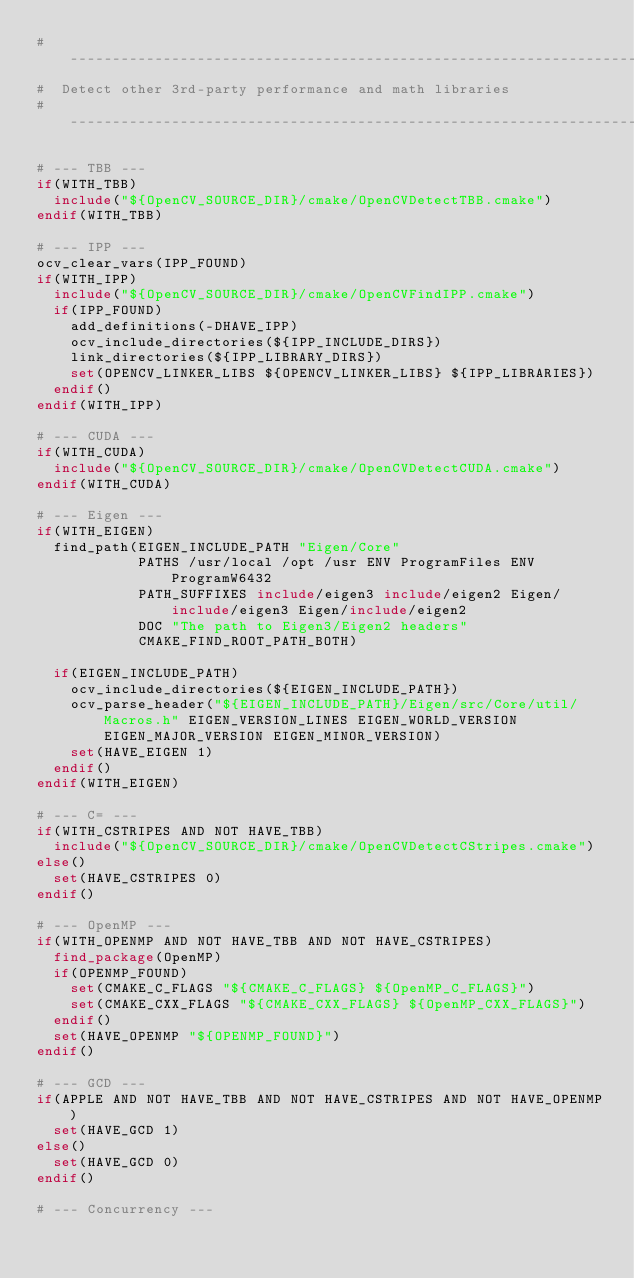<code> <loc_0><loc_0><loc_500><loc_500><_CMake_># ----------------------------------------------------------------------------
#  Detect other 3rd-party performance and math libraries
# ----------------------------------------------------------------------------

# --- TBB ---
if(WITH_TBB)
  include("${OpenCV_SOURCE_DIR}/cmake/OpenCVDetectTBB.cmake")
endif(WITH_TBB)

# --- IPP ---
ocv_clear_vars(IPP_FOUND)
if(WITH_IPP)
  include("${OpenCV_SOURCE_DIR}/cmake/OpenCVFindIPP.cmake")
  if(IPP_FOUND)
    add_definitions(-DHAVE_IPP)
    ocv_include_directories(${IPP_INCLUDE_DIRS})
    link_directories(${IPP_LIBRARY_DIRS})
    set(OPENCV_LINKER_LIBS ${OPENCV_LINKER_LIBS} ${IPP_LIBRARIES})
  endif()
endif(WITH_IPP)

# --- CUDA ---
if(WITH_CUDA)
  include("${OpenCV_SOURCE_DIR}/cmake/OpenCVDetectCUDA.cmake")
endif(WITH_CUDA)

# --- Eigen ---
if(WITH_EIGEN)
  find_path(EIGEN_INCLUDE_PATH "Eigen/Core"
            PATHS /usr/local /opt /usr ENV ProgramFiles ENV ProgramW6432
            PATH_SUFFIXES include/eigen3 include/eigen2 Eigen/include/eigen3 Eigen/include/eigen2
            DOC "The path to Eigen3/Eigen2 headers"
            CMAKE_FIND_ROOT_PATH_BOTH)

  if(EIGEN_INCLUDE_PATH)
    ocv_include_directories(${EIGEN_INCLUDE_PATH})
    ocv_parse_header("${EIGEN_INCLUDE_PATH}/Eigen/src/Core/util/Macros.h" EIGEN_VERSION_LINES EIGEN_WORLD_VERSION EIGEN_MAJOR_VERSION EIGEN_MINOR_VERSION)
    set(HAVE_EIGEN 1)
  endif()
endif(WITH_EIGEN)

# --- C= ---
if(WITH_CSTRIPES AND NOT HAVE_TBB)
  include("${OpenCV_SOURCE_DIR}/cmake/OpenCVDetectCStripes.cmake")
else()
  set(HAVE_CSTRIPES 0)
endif()

# --- OpenMP ---
if(WITH_OPENMP AND NOT HAVE_TBB AND NOT HAVE_CSTRIPES)
  find_package(OpenMP)
  if(OPENMP_FOUND)
    set(CMAKE_C_FLAGS "${CMAKE_C_FLAGS} ${OpenMP_C_FLAGS}")
    set(CMAKE_CXX_FLAGS "${CMAKE_CXX_FLAGS} ${OpenMP_CXX_FLAGS}")
  endif()
  set(HAVE_OPENMP "${OPENMP_FOUND}")
endif()

# --- GCD ---
if(APPLE AND NOT HAVE_TBB AND NOT HAVE_CSTRIPES AND NOT HAVE_OPENMP)
  set(HAVE_GCD 1)
else()
  set(HAVE_GCD 0)
endif()

# --- Concurrency ---</code> 